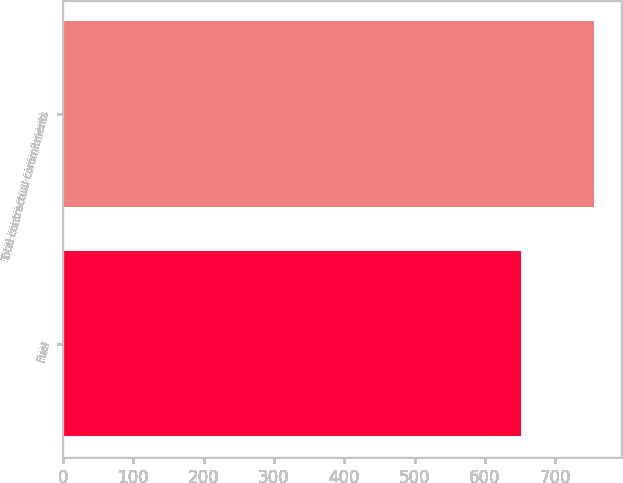<chart> <loc_0><loc_0><loc_500><loc_500><bar_chart><fcel>Fuel<fcel>Total contractual commitments<nl><fcel>651.6<fcel>755.6<nl></chart> 